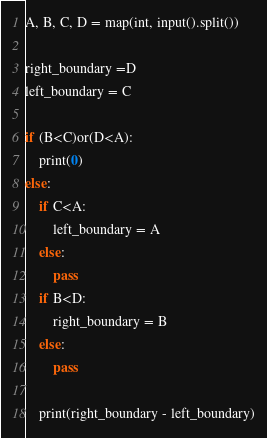Convert code to text. <code><loc_0><loc_0><loc_500><loc_500><_Python_>A, B, C, D = map(int, input().split())

right_boundary =D
left_boundary = C

if (B<C)or(D<A):
    print(0)
else:
    if C<A:
        left_boundary = A
    else:
        pass
    if B<D:
        right_boundary = B
    else:
        pass
    
    print(right_boundary - left_boundary)</code> 